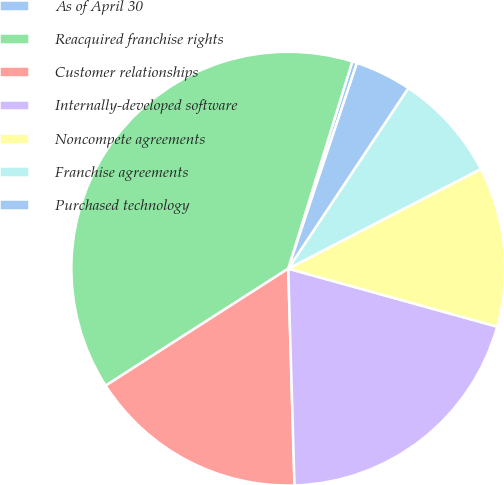Convert chart. <chart><loc_0><loc_0><loc_500><loc_500><pie_chart><fcel>As of April 30<fcel>Reacquired franchise rights<fcel>Customer relationships<fcel>Internally-developed software<fcel>Noncompete agreements<fcel>Franchise agreements<fcel>Purchased technology<nl><fcel>0.36%<fcel>38.84%<fcel>16.39%<fcel>20.23%<fcel>11.91%<fcel>8.06%<fcel>4.21%<nl></chart> 